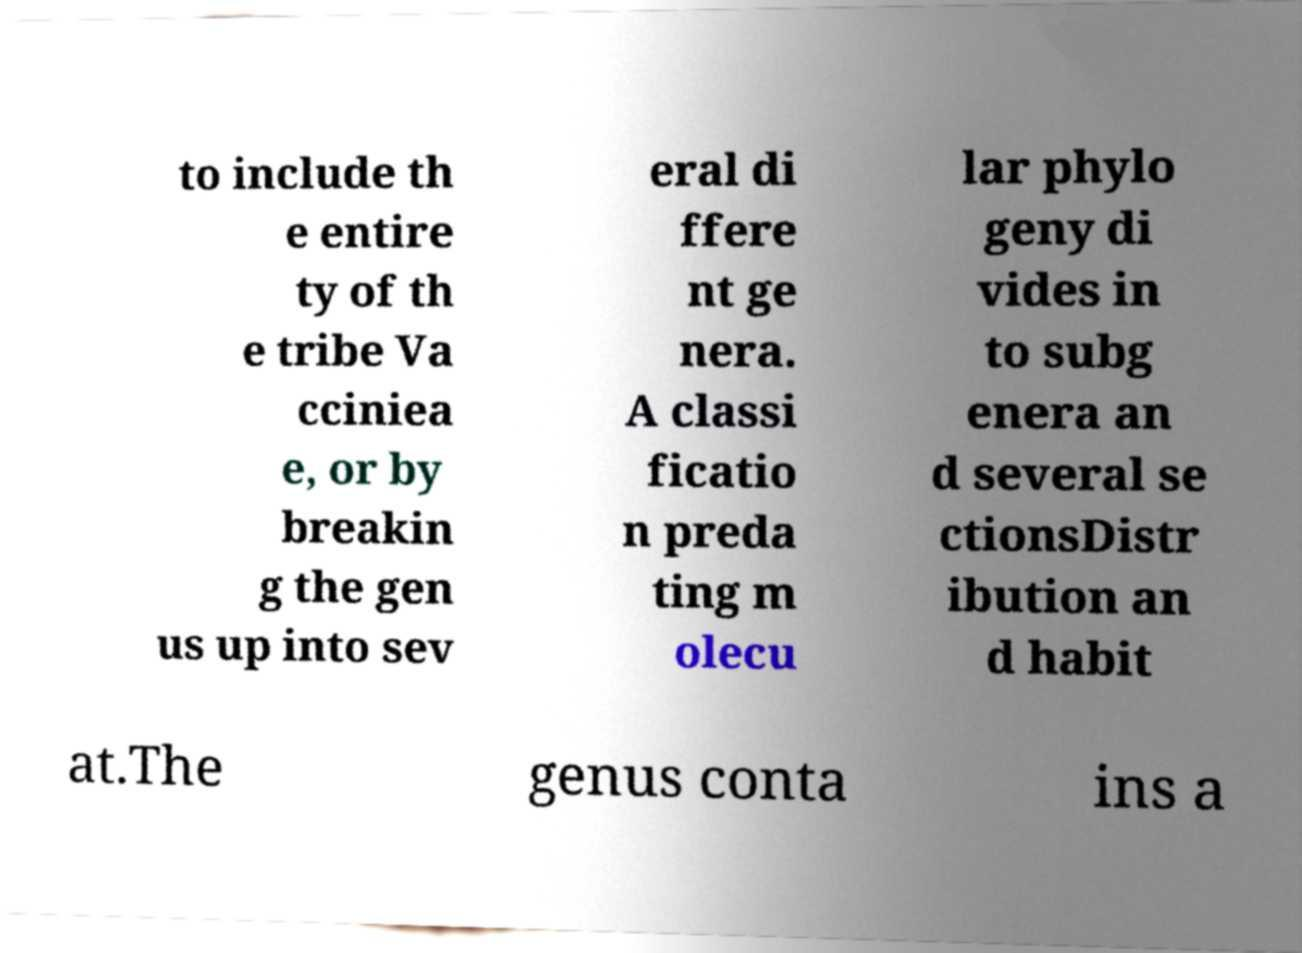Can you read and provide the text displayed in the image?This photo seems to have some interesting text. Can you extract and type it out for me? to include th e entire ty of th e tribe Va cciniea e, or by breakin g the gen us up into sev eral di ffere nt ge nera. A classi ficatio n preda ting m olecu lar phylo geny di vides in to subg enera an d several se ctionsDistr ibution an d habit at.The genus conta ins a 